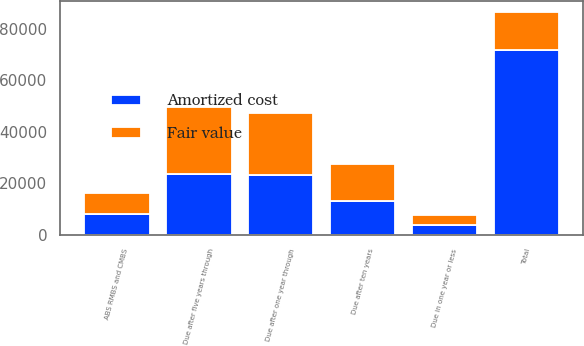Convert chart to OTSL. <chart><loc_0><loc_0><loc_500><loc_500><stacked_bar_chart><ecel><fcel>Due in one year or less<fcel>Due after one year through<fcel>Due after five years through<fcel>Due after ten years<fcel>ABS RMBS and CMBS<fcel>Total<nl><fcel>Amortized cost<fcel>3825<fcel>23168<fcel>23808<fcel>12981<fcel>8133<fcel>71915<nl><fcel>Fair value<fcel>3872<fcel>24324<fcel>25973<fcel>14694<fcel>8154<fcel>14694<nl></chart> 